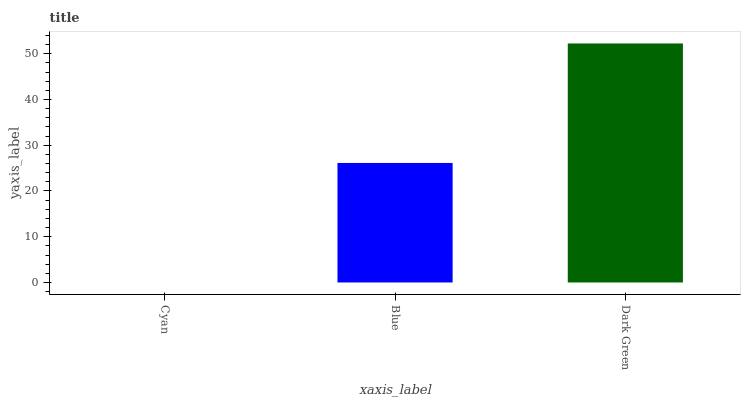Is Cyan the minimum?
Answer yes or no. Yes. Is Dark Green the maximum?
Answer yes or no. Yes. Is Blue the minimum?
Answer yes or no. No. Is Blue the maximum?
Answer yes or no. No. Is Blue greater than Cyan?
Answer yes or no. Yes. Is Cyan less than Blue?
Answer yes or no. Yes. Is Cyan greater than Blue?
Answer yes or no. No. Is Blue less than Cyan?
Answer yes or no. No. Is Blue the high median?
Answer yes or no. Yes. Is Blue the low median?
Answer yes or no. Yes. Is Cyan the high median?
Answer yes or no. No. Is Cyan the low median?
Answer yes or no. No. 